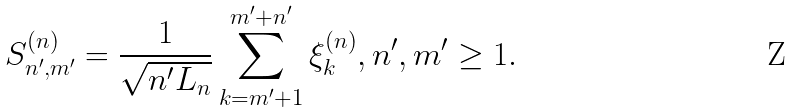Convert formula to latex. <formula><loc_0><loc_0><loc_500><loc_500>S _ { n ^ { \prime } , m ^ { \prime } } ^ { ( n ) } = \frac { 1 } { \sqrt { n ^ { \prime } L _ { n } } } \sum _ { k = m ^ { \prime } + 1 } ^ { m ^ { \prime } + n ^ { \prime } } \xi _ { k } ^ { ( n ) } , n ^ { \prime } , m ^ { \prime } \geq 1 .</formula> 